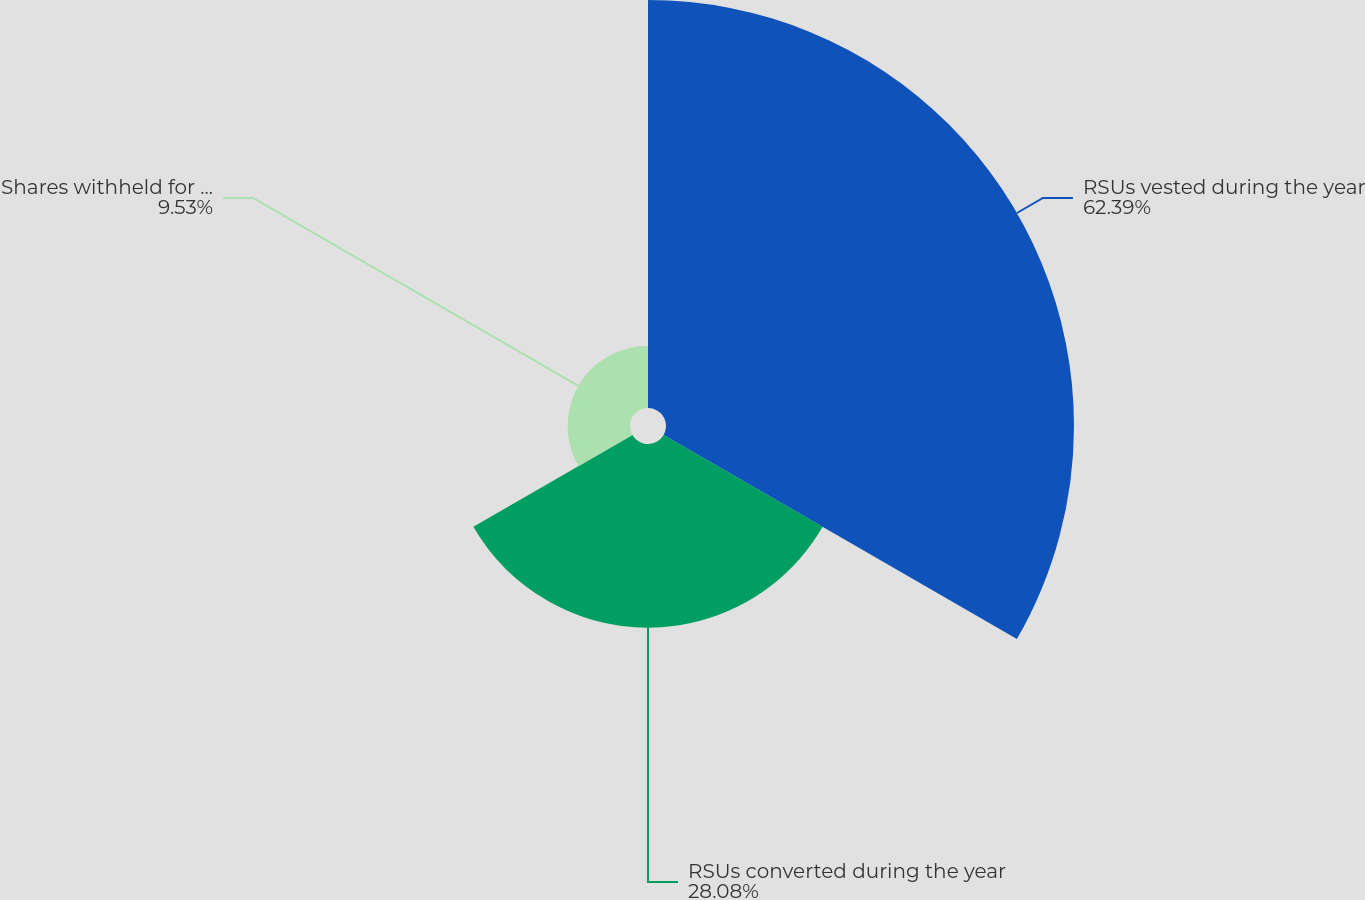Convert chart to OTSL. <chart><loc_0><loc_0><loc_500><loc_500><pie_chart><fcel>RSUs vested during the year<fcel>RSUs converted during the year<fcel>Shares withheld for taxes<nl><fcel>62.39%<fcel>28.08%<fcel>9.53%<nl></chart> 